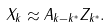<formula> <loc_0><loc_0><loc_500><loc_500>X _ { k } \approx A _ { k - k ^ { * } } Z _ { k ^ { * } } .</formula> 